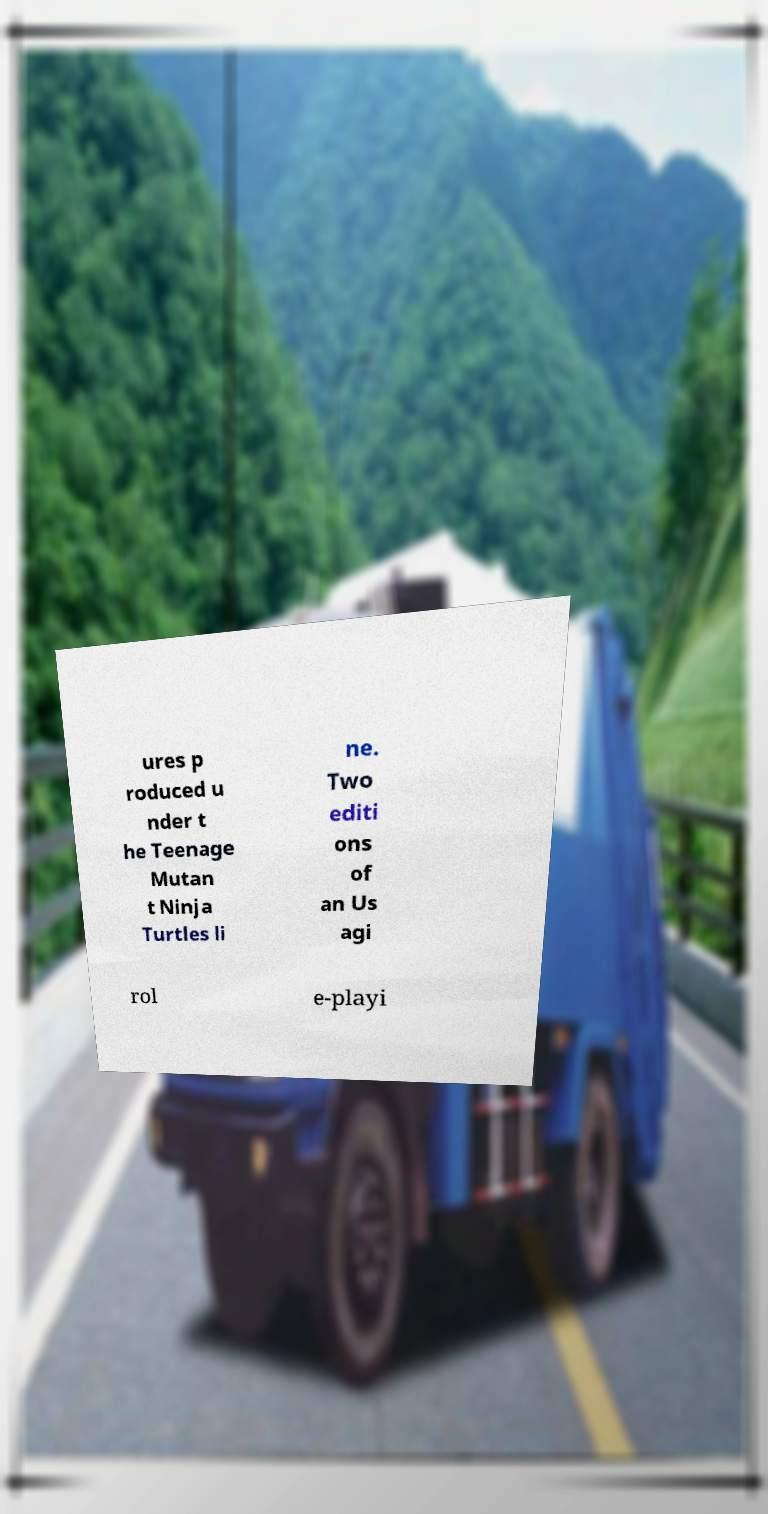What messages or text are displayed in this image? I need them in a readable, typed format. ures p roduced u nder t he Teenage Mutan t Ninja Turtles li ne. Two editi ons of an Us agi rol e-playi 